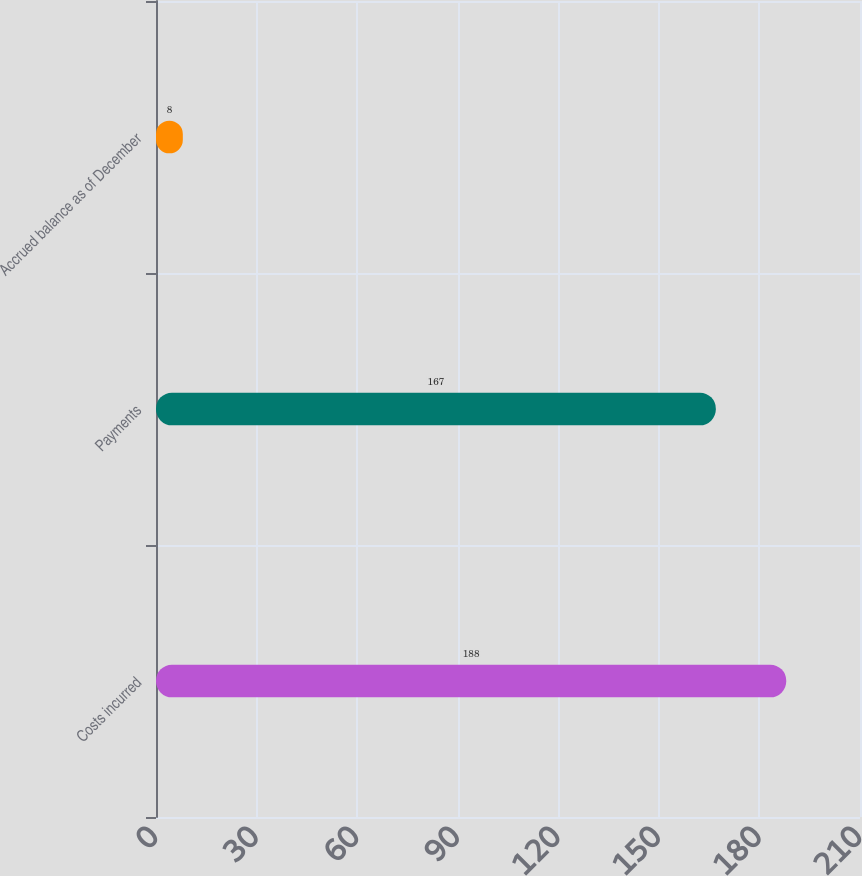<chart> <loc_0><loc_0><loc_500><loc_500><bar_chart><fcel>Costs incurred<fcel>Payments<fcel>Accrued balance as of December<nl><fcel>188<fcel>167<fcel>8<nl></chart> 